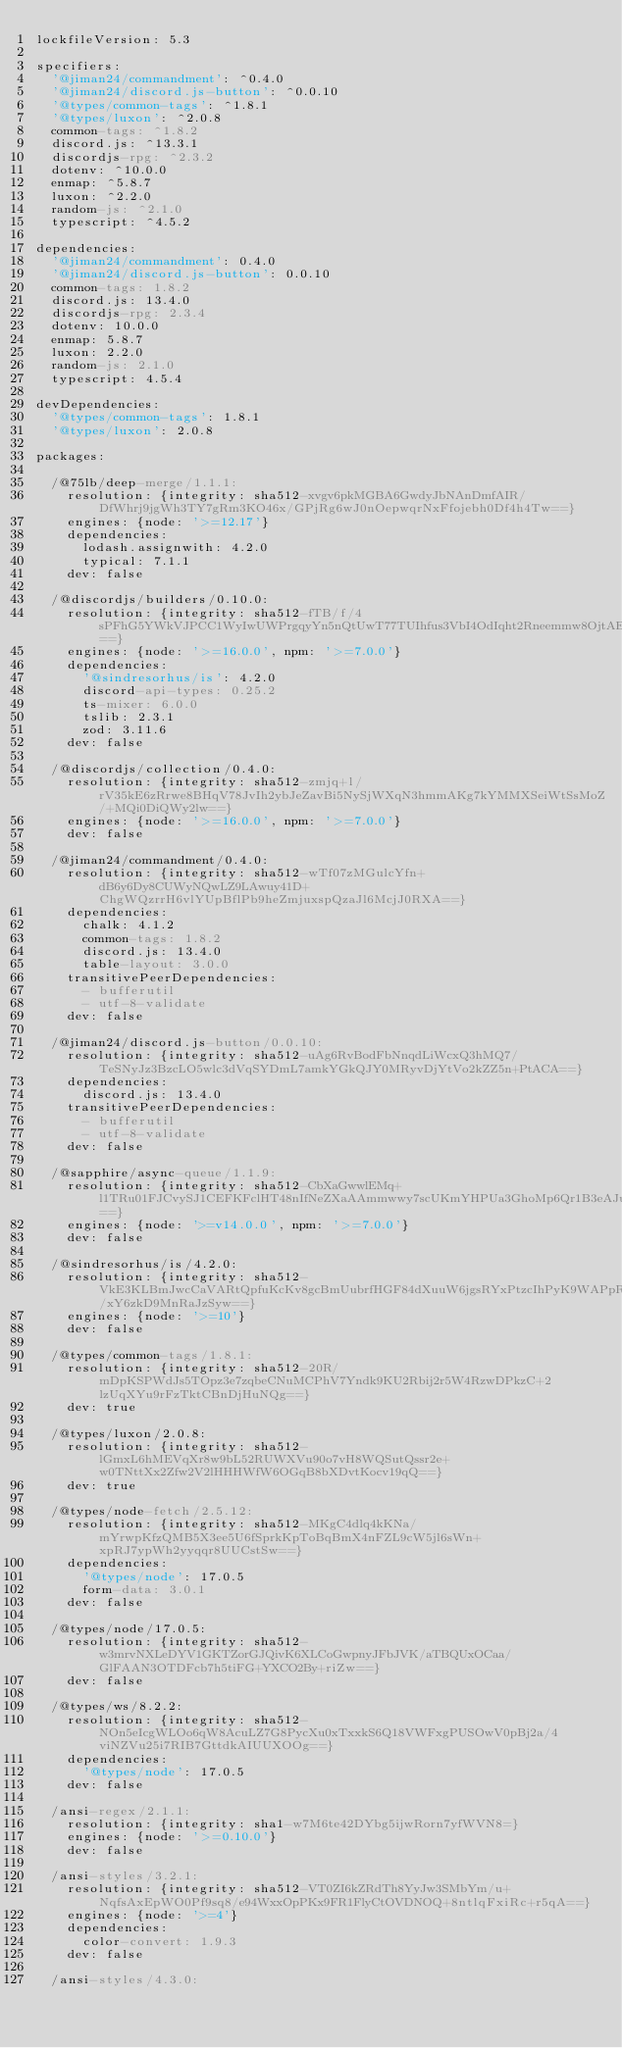<code> <loc_0><loc_0><loc_500><loc_500><_YAML_>lockfileVersion: 5.3

specifiers:
  '@jiman24/commandment': ^0.4.0
  '@jiman24/discord.js-button': ^0.0.10
  '@types/common-tags': ^1.8.1
  '@types/luxon': ^2.0.8
  common-tags: ^1.8.2
  discord.js: ^13.3.1
  discordjs-rpg: ^2.3.2
  dotenv: ^10.0.0
  enmap: ^5.8.7
  luxon: ^2.2.0
  random-js: ^2.1.0
  typescript: ^4.5.2

dependencies:
  '@jiman24/commandment': 0.4.0
  '@jiman24/discord.js-button': 0.0.10
  common-tags: 1.8.2
  discord.js: 13.4.0
  discordjs-rpg: 2.3.4
  dotenv: 10.0.0
  enmap: 5.8.7
  luxon: 2.2.0
  random-js: 2.1.0
  typescript: 4.5.4

devDependencies:
  '@types/common-tags': 1.8.1
  '@types/luxon': 2.0.8

packages:

  /@75lb/deep-merge/1.1.1:
    resolution: {integrity: sha512-xvgv6pkMGBA6GwdyJbNAnDmfAIR/DfWhrj9jgWh3TY7gRm3KO46x/GPjRg6wJ0nOepwqrNxFfojebh0Df4h4Tw==}
    engines: {node: '>=12.17'}
    dependencies:
      lodash.assignwith: 4.2.0
      typical: 7.1.1
    dev: false

  /@discordjs/builders/0.10.0:
    resolution: {integrity: sha512-fTB/f/4sPFhG5YWkVJPCC1WyIwUWPrgqyYn5nQtUwT77TUIhfus3VbI4OdIqht2Rneemmw8OjtAEBY3ENB0XWQ==}
    engines: {node: '>=16.0.0', npm: '>=7.0.0'}
    dependencies:
      '@sindresorhus/is': 4.2.0
      discord-api-types: 0.25.2
      ts-mixer: 6.0.0
      tslib: 2.3.1
      zod: 3.11.6
    dev: false

  /@discordjs/collection/0.4.0:
    resolution: {integrity: sha512-zmjq+l/rV35kE6zRrwe8BHqV78JvIh2ybJeZavBi5NySjWXqN3hmmAKg7kYMMXSeiWtSsMoZ/+MQi0DiQWy2lw==}
    engines: {node: '>=16.0.0', npm: '>=7.0.0'}
    dev: false

  /@jiman24/commandment/0.4.0:
    resolution: {integrity: sha512-wTf07zMGulcYfn+dB6y6Dy8CUWyNQwLZ9LAwuy41D+ChgWQzrrH6vlYUpBflPb9heZmjuxspQzaJl6McjJ0RXA==}
    dependencies:
      chalk: 4.1.2
      common-tags: 1.8.2
      discord.js: 13.4.0
      table-layout: 3.0.0
    transitivePeerDependencies:
      - bufferutil
      - utf-8-validate
    dev: false

  /@jiman24/discord.js-button/0.0.10:
    resolution: {integrity: sha512-uAg6RvBodFbNnqdLiWcxQ3hMQ7/TeSNyJz3BzcLO5wlc3dVqSYDmL7amkYGkQJY0MRyvDjYtVo2kZZ5n+PtACA==}
    dependencies:
      discord.js: 13.4.0
    transitivePeerDependencies:
      - bufferutil
      - utf-8-validate
    dev: false

  /@sapphire/async-queue/1.1.9:
    resolution: {integrity: sha512-CbXaGwwlEMq+l1TRu01FJCvySJ1CEFKFclHT48nIfNeZXaAAmmwwy7scUKmYHPUa3GhoMp6Qr1B3eAJux6XgOQ==}
    engines: {node: '>=v14.0.0', npm: '>=7.0.0'}
    dev: false

  /@sindresorhus/is/4.2.0:
    resolution: {integrity: sha512-VkE3KLBmJwcCaVARtQpfuKcKv8gcBmUubrfHGF84dXuuW6jgsRYxPtzcIhPyK9WAPpRt2/xY6zkD9MnRaJzSyw==}
    engines: {node: '>=10'}
    dev: false

  /@types/common-tags/1.8.1:
    resolution: {integrity: sha512-20R/mDpKSPWdJs5TOpz3e7zqbeCNuMCPhV7Yndk9KU2Rbij2r5W4RzwDPkzC+2lzUqXYu9rFzTktCBnDjHuNQg==}
    dev: true

  /@types/luxon/2.0.8:
    resolution: {integrity: sha512-lGmxL6hMEVqXr8w9bL52RUWXVu90o7vH8WQSutQssr2e+w0TNttXx2Zfw2V2lHHHWfW6OGqB8bXDvtKocv19qQ==}
    dev: true

  /@types/node-fetch/2.5.12:
    resolution: {integrity: sha512-MKgC4dlq4kKNa/mYrwpKfzQMB5X3ee5U6fSprkKpToBqBmX4nFZL9cW5jl6sWn+xpRJ7ypWh2yyqqr8UUCstSw==}
    dependencies:
      '@types/node': 17.0.5
      form-data: 3.0.1
    dev: false

  /@types/node/17.0.5:
    resolution: {integrity: sha512-w3mrvNXLeDYV1GKTZorGJQivK6XLCoGwpnyJFbJVK/aTBQUxOCaa/GlFAAN3OTDFcb7h5tiFG+YXCO2By+riZw==}
    dev: false

  /@types/ws/8.2.2:
    resolution: {integrity: sha512-NOn5eIcgWLOo6qW8AcuLZ7G8PycXu0xTxxkS6Q18VWFxgPUSOwV0pBj2a/4viNZVu25i7RIB7GttdkAIUUXOOg==}
    dependencies:
      '@types/node': 17.0.5
    dev: false

  /ansi-regex/2.1.1:
    resolution: {integrity: sha1-w7M6te42DYbg5ijwRorn7yfWVN8=}
    engines: {node: '>=0.10.0'}
    dev: false

  /ansi-styles/3.2.1:
    resolution: {integrity: sha512-VT0ZI6kZRdTh8YyJw3SMbYm/u+NqfsAxEpWO0Pf9sq8/e94WxxOpPKx9FR1FlyCtOVDNOQ+8ntlqFxiRc+r5qA==}
    engines: {node: '>=4'}
    dependencies:
      color-convert: 1.9.3
    dev: false

  /ansi-styles/4.3.0:</code> 